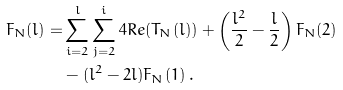Convert formula to latex. <formula><loc_0><loc_0><loc_500><loc_500>F _ { N } ( l ) = & \sum ^ { l } _ { i = 2 } \sum ^ { i } _ { j = 2 } 4 R e ( T _ { N } ( l ) ) + \left ( \frac { l ^ { 2 } } { 2 } - \frac { l } { 2 } \right ) F _ { N } ( 2 ) \\ & - ( l ^ { 2 } - 2 l ) F _ { N } ( 1 ) \, .</formula> 